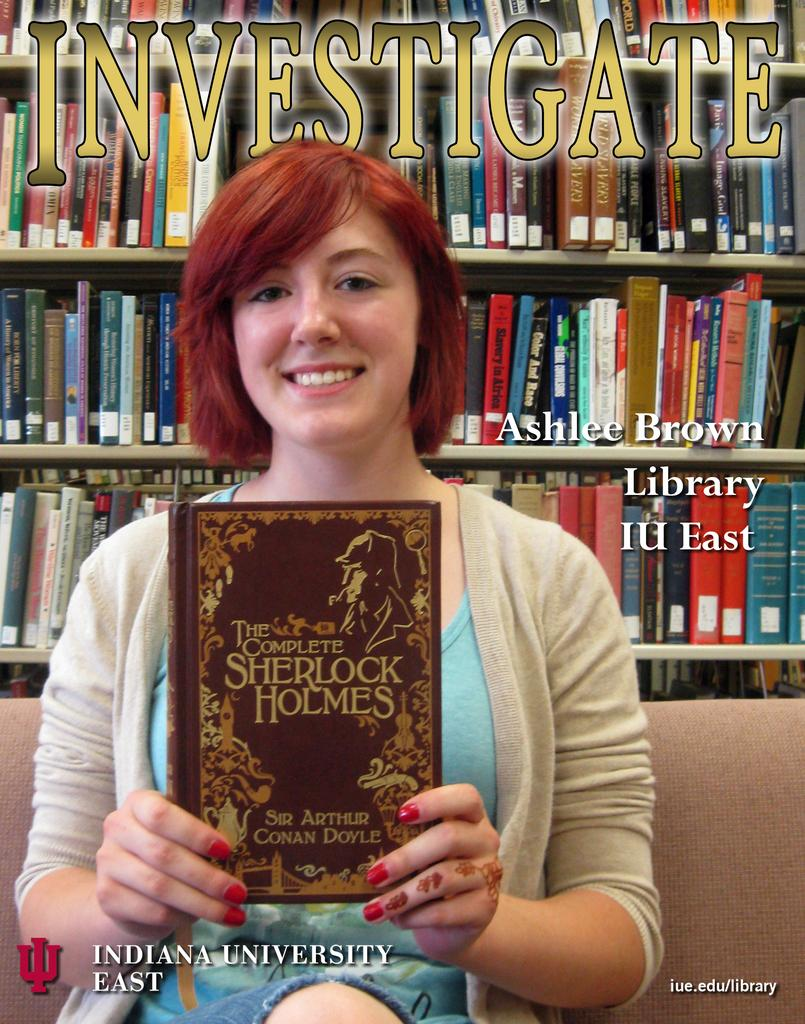Provide a one-sentence caption for the provided image. Indiana University East logo with The Complete Sherlock Holmes book. 